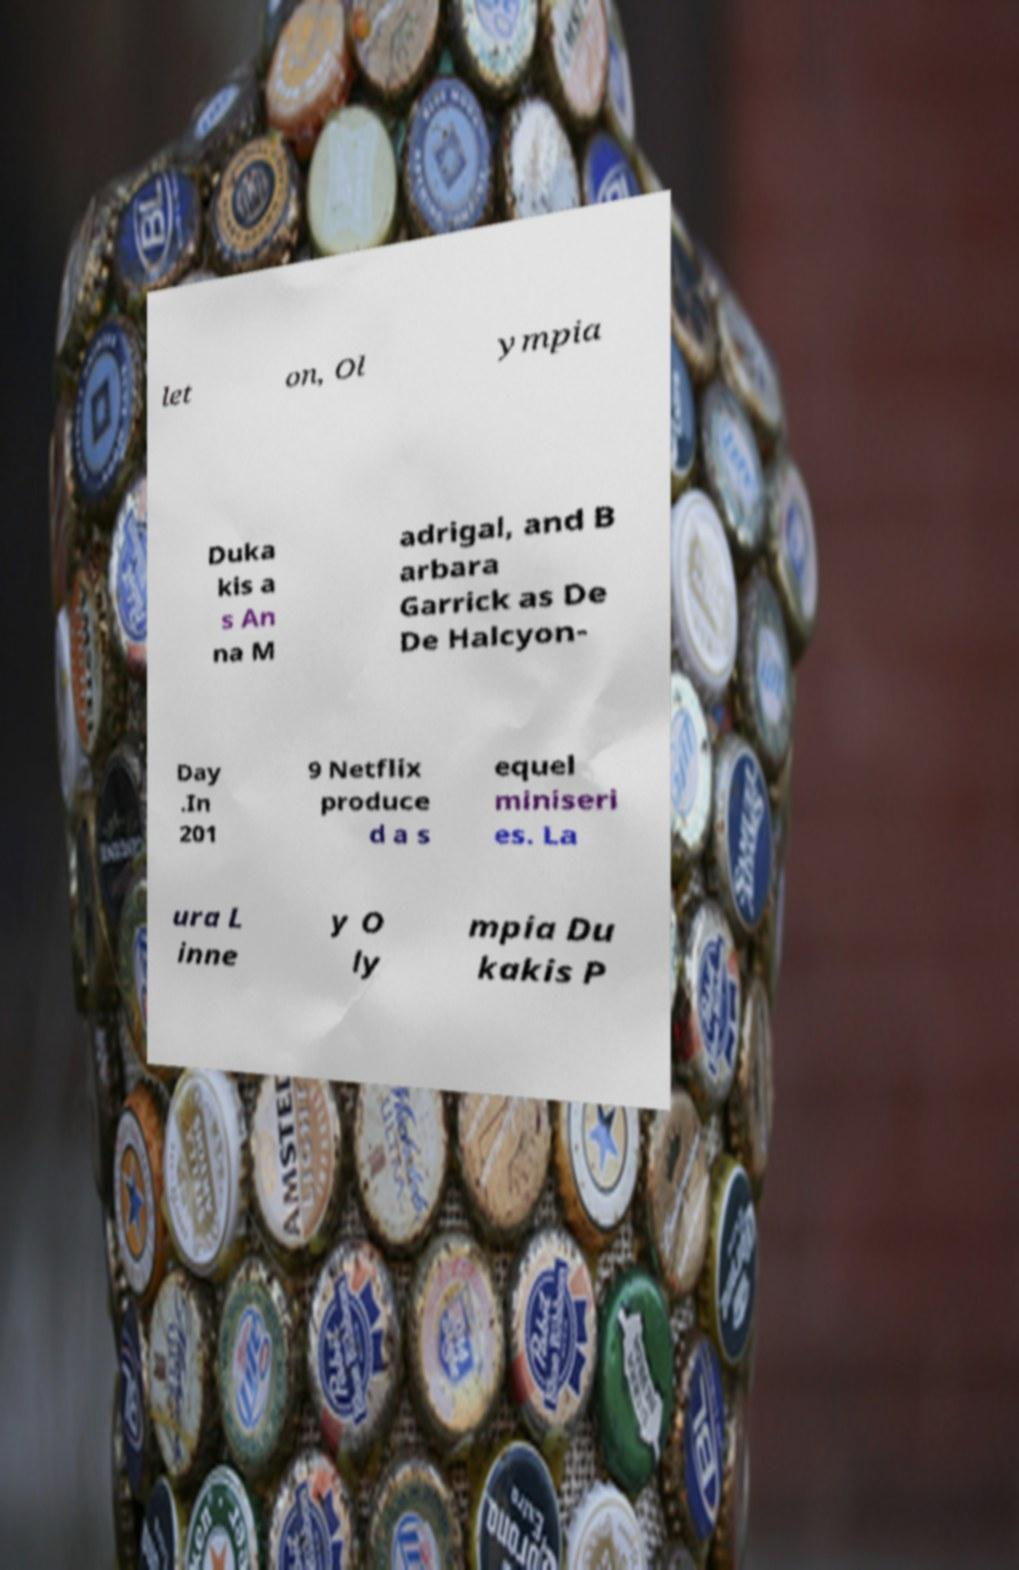Could you extract and type out the text from this image? let on, Ol ympia Duka kis a s An na M adrigal, and B arbara Garrick as De De Halcyon- Day .In 201 9 Netflix produce d a s equel miniseri es. La ura L inne y O ly mpia Du kakis P 